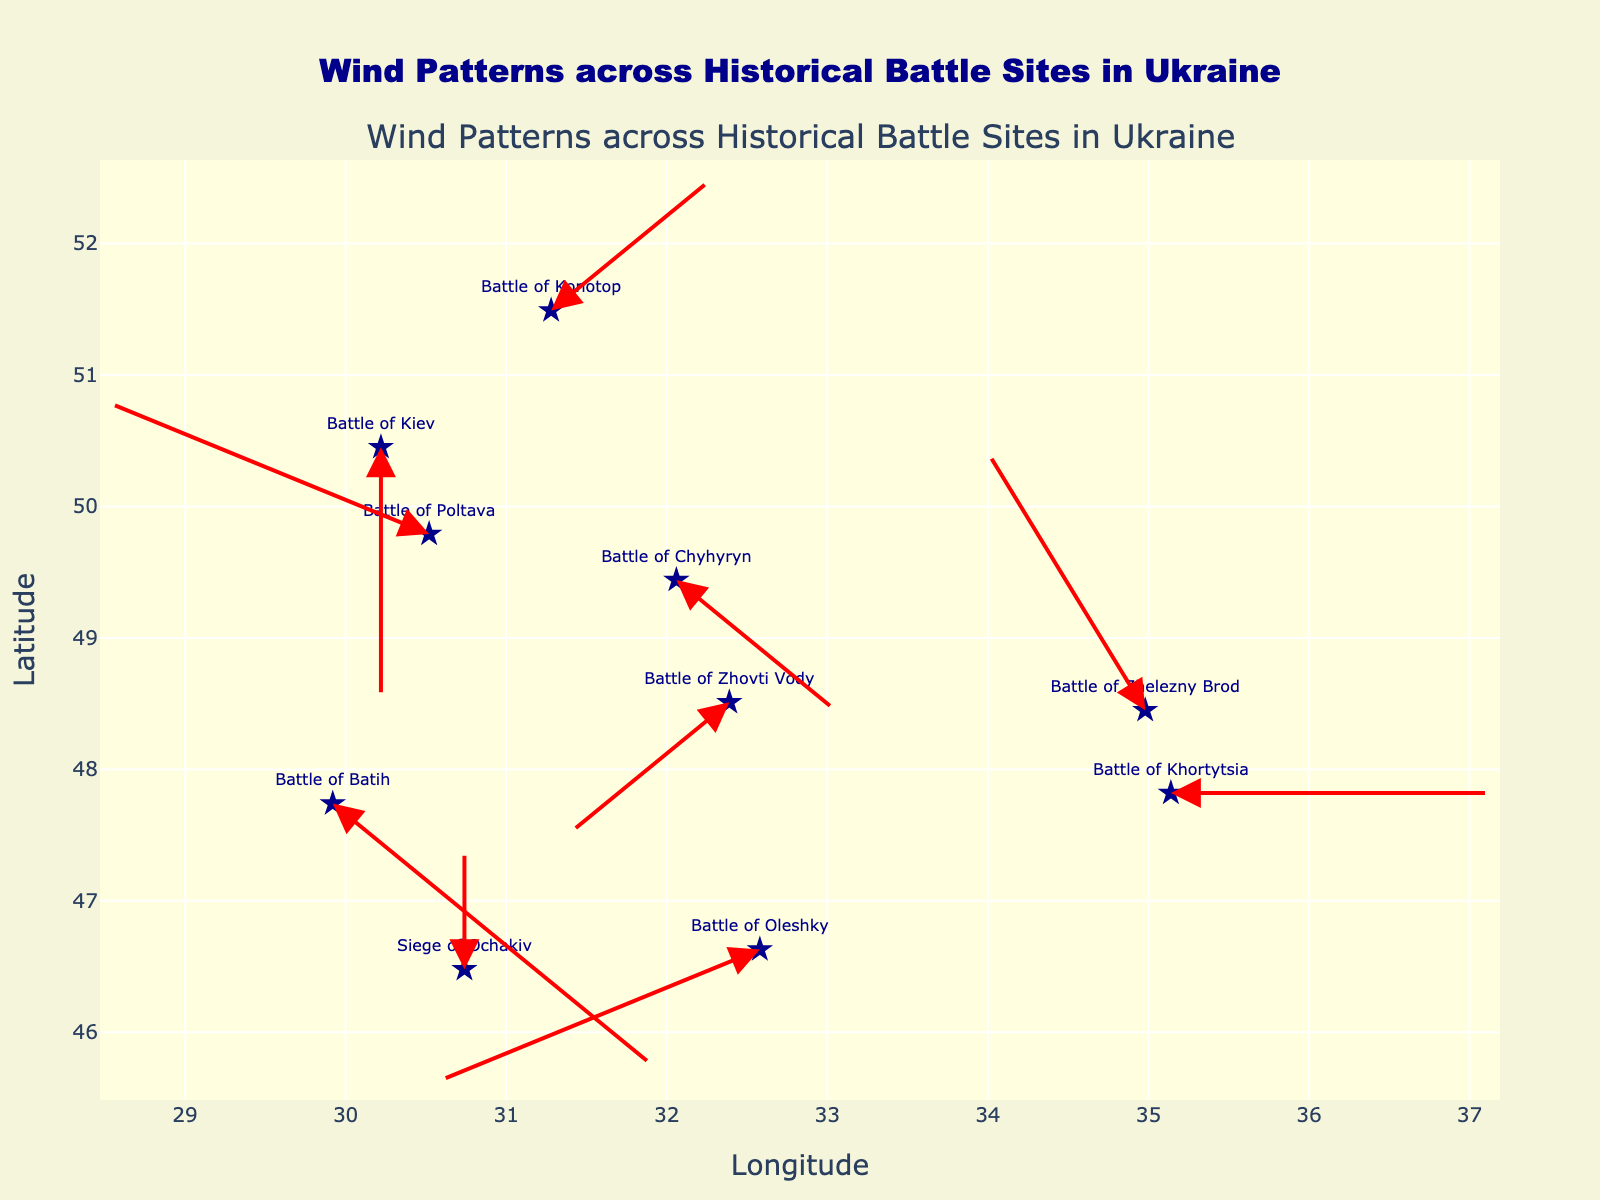How many historical battle sites are represented in the figure? Count the number of unique sites marked on the plot with text labels.
Answer: 10 What is the title of the figure? Check the title at the top of the figure.
Answer: Wind Patterns across Historical Battle Sites in Ukraine What is the direction of the wind vector at the Battle of Poltava? Look at the arrow originating from the Battle of Poltava label: it goes left and slightly up.
Answer: West-Northwest Which two battle sites have the strongest opposing wind directions? Compare the magnitude and direction of the vectors for each site. The Battle of Khortytsia has a vector pointing directly east, while the Battle of Batih has a vector pointing directly west.
Answer: Battle of Khortytsia and Battle of Batih What is the overall direction of the wind vector at the Battle of Kiev? Observe the vector's direction at the Battle of Kiev, which is downward.
Answer: South Is the wind at the Battle of Konotop blowing towards the South or the North? The arrow at the Battle of Konotop label points upward.
Answer: North What is the longest wind vector in the plot? Measure the length of each vector: the largest vector has a u (2) component and points east: Battle of Khortytsia. Additional factors include their respective magnitudes.
Answer: Battle of Khortytsia Are there any battle sites where the wind is blowing in a completely vertical direction? Look for vectors with only 'u' or only 'v' components to see if any points straight up or down. The Battle of Kiev and Siege of Ochakiv have vertical vectors.
Answer: Yes, Battle of Kiev and Siege of Ochakiv Which battle site is located the furthest south? Identify the site with the lowest latitude coordinate.
Answer: Siege of Ochakiv At which battle site does the wind blow in a mostly northward direction without any horizontal movement? Find vectors with u (0) and positive v: The Siege of Ochakiv has a vector pointing straight up.
Answer: Siege of Ochakiv 